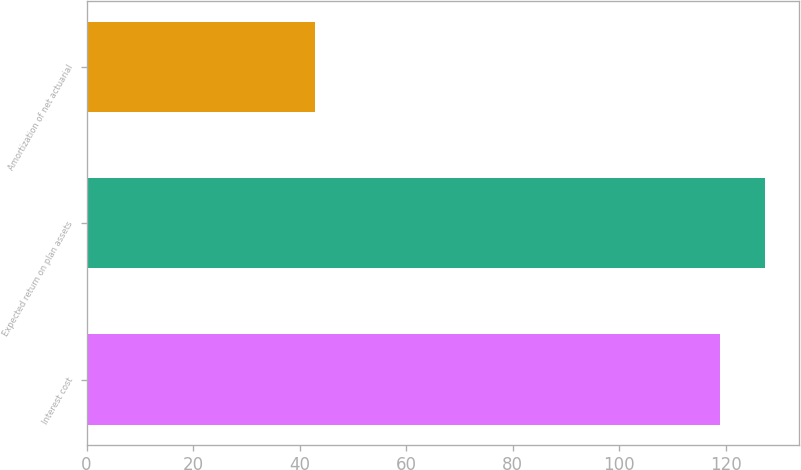Convert chart to OTSL. <chart><loc_0><loc_0><loc_500><loc_500><bar_chart><fcel>Interest cost<fcel>Expected return on plan assets<fcel>Amortization of net actuarial<nl><fcel>119<fcel>127.4<fcel>43<nl></chart> 